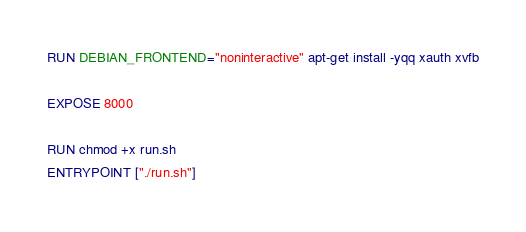<code> <loc_0><loc_0><loc_500><loc_500><_Dockerfile_>RUN DEBIAN_FRONTEND="noninteractive" apt-get install -yqq xauth xvfb

EXPOSE 8000

RUN chmod +x run.sh
ENTRYPOINT ["./run.sh"]
</code> 